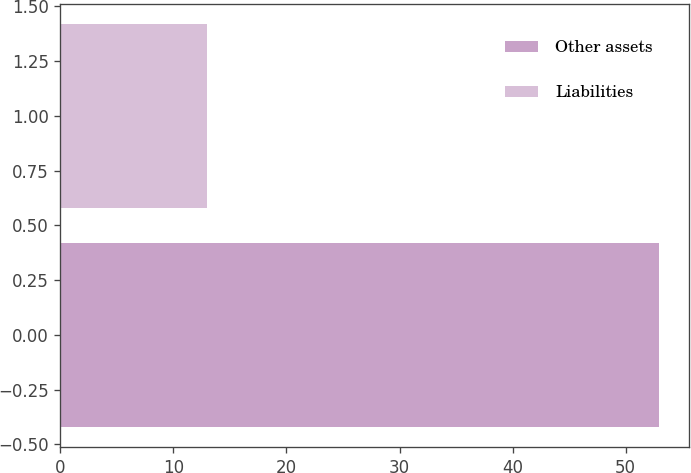<chart> <loc_0><loc_0><loc_500><loc_500><bar_chart><fcel>Other assets<fcel>Liabilities<nl><fcel>53<fcel>13<nl></chart> 